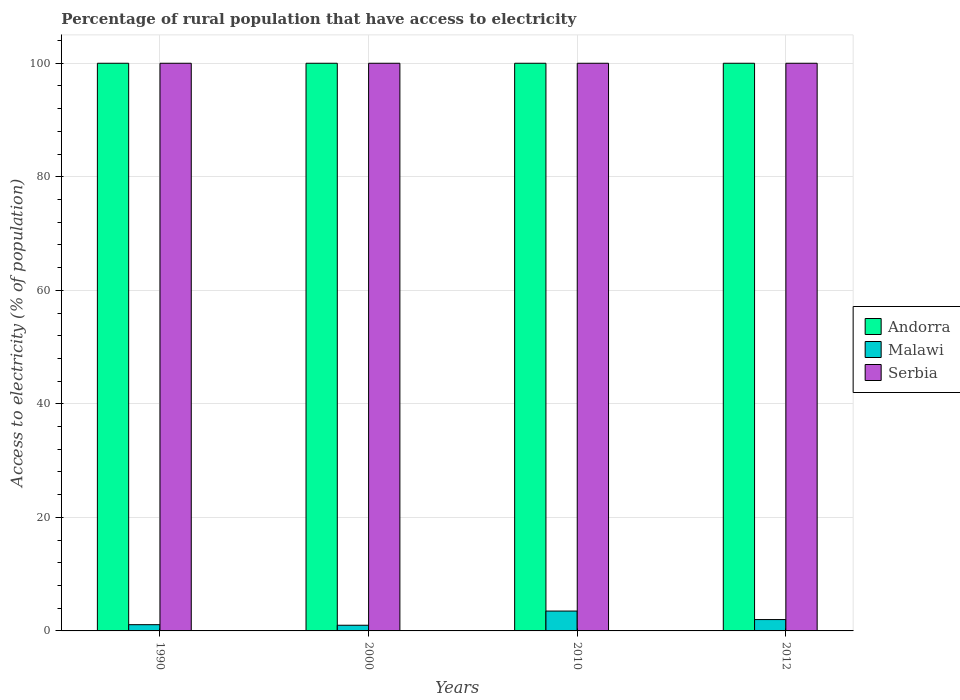How many different coloured bars are there?
Give a very brief answer. 3. How many groups of bars are there?
Give a very brief answer. 4. How many bars are there on the 2nd tick from the right?
Provide a short and direct response. 3. What is the label of the 4th group of bars from the left?
Make the answer very short. 2012. In how many cases, is the number of bars for a given year not equal to the number of legend labels?
Keep it short and to the point. 0. What is the percentage of rural population that have access to electricity in Serbia in 1990?
Give a very brief answer. 100. Across all years, what is the maximum percentage of rural population that have access to electricity in Andorra?
Offer a very short reply. 100. Across all years, what is the minimum percentage of rural population that have access to electricity in Serbia?
Your answer should be very brief. 100. In which year was the percentage of rural population that have access to electricity in Serbia maximum?
Offer a very short reply. 1990. What is the total percentage of rural population that have access to electricity in Andorra in the graph?
Your answer should be compact. 400. What is the difference between the percentage of rural population that have access to electricity in Serbia in 2012 and the percentage of rural population that have access to electricity in Malawi in 1990?
Provide a short and direct response. 98.9. What is the average percentage of rural population that have access to electricity in Serbia per year?
Offer a very short reply. 100. What is the ratio of the percentage of rural population that have access to electricity in Andorra in 2010 to that in 2012?
Your response must be concise. 1. Is the percentage of rural population that have access to electricity in Malawi in 1990 less than that in 2000?
Ensure brevity in your answer.  No. What is the difference between the highest and the second highest percentage of rural population that have access to electricity in Serbia?
Offer a terse response. 0. What does the 3rd bar from the left in 2000 represents?
Your response must be concise. Serbia. What does the 3rd bar from the right in 1990 represents?
Offer a very short reply. Andorra. How many bars are there?
Give a very brief answer. 12. What is the difference between two consecutive major ticks on the Y-axis?
Offer a very short reply. 20. Does the graph contain grids?
Provide a short and direct response. Yes. Where does the legend appear in the graph?
Your answer should be very brief. Center right. How many legend labels are there?
Your response must be concise. 3. How are the legend labels stacked?
Offer a very short reply. Vertical. What is the title of the graph?
Provide a succinct answer. Percentage of rural population that have access to electricity. What is the label or title of the X-axis?
Make the answer very short. Years. What is the label or title of the Y-axis?
Provide a short and direct response. Access to electricity (% of population). What is the Access to electricity (% of population) of Andorra in 1990?
Ensure brevity in your answer.  100. What is the Access to electricity (% of population) in Andorra in 2010?
Provide a succinct answer. 100. What is the Access to electricity (% of population) in Malawi in 2010?
Give a very brief answer. 3.5. Across all years, what is the maximum Access to electricity (% of population) in Andorra?
Ensure brevity in your answer.  100. Across all years, what is the maximum Access to electricity (% of population) of Serbia?
Give a very brief answer. 100. Across all years, what is the minimum Access to electricity (% of population) of Malawi?
Make the answer very short. 1. Across all years, what is the minimum Access to electricity (% of population) in Serbia?
Ensure brevity in your answer.  100. What is the total Access to electricity (% of population) of Serbia in the graph?
Offer a terse response. 400. What is the difference between the Access to electricity (% of population) of Malawi in 1990 and that in 2000?
Make the answer very short. 0.1. What is the difference between the Access to electricity (% of population) in Serbia in 1990 and that in 2000?
Your answer should be very brief. 0. What is the difference between the Access to electricity (% of population) in Andorra in 1990 and that in 2010?
Provide a succinct answer. 0. What is the difference between the Access to electricity (% of population) in Serbia in 1990 and that in 2010?
Your response must be concise. 0. What is the difference between the Access to electricity (% of population) in Malawi in 1990 and that in 2012?
Your answer should be very brief. -0.9. What is the difference between the Access to electricity (% of population) of Serbia in 1990 and that in 2012?
Your answer should be very brief. 0. What is the difference between the Access to electricity (% of population) in Andorra in 2000 and that in 2010?
Your answer should be very brief. 0. What is the difference between the Access to electricity (% of population) in Malawi in 2000 and that in 2010?
Ensure brevity in your answer.  -2.5. What is the difference between the Access to electricity (% of population) of Andorra in 2000 and that in 2012?
Offer a very short reply. 0. What is the difference between the Access to electricity (% of population) of Serbia in 2000 and that in 2012?
Offer a terse response. 0. What is the difference between the Access to electricity (% of population) in Andorra in 2010 and that in 2012?
Keep it short and to the point. 0. What is the difference between the Access to electricity (% of population) in Malawi in 2010 and that in 2012?
Your response must be concise. 1.5. What is the difference between the Access to electricity (% of population) of Serbia in 2010 and that in 2012?
Your answer should be compact. 0. What is the difference between the Access to electricity (% of population) in Malawi in 1990 and the Access to electricity (% of population) in Serbia in 2000?
Your answer should be compact. -98.9. What is the difference between the Access to electricity (% of population) in Andorra in 1990 and the Access to electricity (% of population) in Malawi in 2010?
Keep it short and to the point. 96.5. What is the difference between the Access to electricity (% of population) of Malawi in 1990 and the Access to electricity (% of population) of Serbia in 2010?
Your answer should be very brief. -98.9. What is the difference between the Access to electricity (% of population) in Andorra in 1990 and the Access to electricity (% of population) in Malawi in 2012?
Make the answer very short. 98. What is the difference between the Access to electricity (% of population) of Malawi in 1990 and the Access to electricity (% of population) of Serbia in 2012?
Provide a succinct answer. -98.9. What is the difference between the Access to electricity (% of population) of Andorra in 2000 and the Access to electricity (% of population) of Malawi in 2010?
Offer a terse response. 96.5. What is the difference between the Access to electricity (% of population) of Andorra in 2000 and the Access to electricity (% of population) of Serbia in 2010?
Offer a terse response. 0. What is the difference between the Access to electricity (% of population) of Malawi in 2000 and the Access to electricity (% of population) of Serbia in 2010?
Your answer should be very brief. -99. What is the difference between the Access to electricity (% of population) in Andorra in 2000 and the Access to electricity (% of population) in Malawi in 2012?
Provide a short and direct response. 98. What is the difference between the Access to electricity (% of population) of Andorra in 2000 and the Access to electricity (% of population) of Serbia in 2012?
Your answer should be very brief. 0. What is the difference between the Access to electricity (% of population) of Malawi in 2000 and the Access to electricity (% of population) of Serbia in 2012?
Your answer should be very brief. -99. What is the difference between the Access to electricity (% of population) in Andorra in 2010 and the Access to electricity (% of population) in Serbia in 2012?
Give a very brief answer. 0. What is the difference between the Access to electricity (% of population) in Malawi in 2010 and the Access to electricity (% of population) in Serbia in 2012?
Offer a very short reply. -96.5. What is the average Access to electricity (% of population) in Serbia per year?
Your answer should be very brief. 100. In the year 1990, what is the difference between the Access to electricity (% of population) in Andorra and Access to electricity (% of population) in Malawi?
Your response must be concise. 98.9. In the year 1990, what is the difference between the Access to electricity (% of population) of Malawi and Access to electricity (% of population) of Serbia?
Your answer should be very brief. -98.9. In the year 2000, what is the difference between the Access to electricity (% of population) of Malawi and Access to electricity (% of population) of Serbia?
Make the answer very short. -99. In the year 2010, what is the difference between the Access to electricity (% of population) in Andorra and Access to electricity (% of population) in Malawi?
Keep it short and to the point. 96.5. In the year 2010, what is the difference between the Access to electricity (% of population) in Andorra and Access to electricity (% of population) in Serbia?
Provide a short and direct response. 0. In the year 2010, what is the difference between the Access to electricity (% of population) in Malawi and Access to electricity (% of population) in Serbia?
Ensure brevity in your answer.  -96.5. In the year 2012, what is the difference between the Access to electricity (% of population) of Andorra and Access to electricity (% of population) of Serbia?
Make the answer very short. 0. In the year 2012, what is the difference between the Access to electricity (% of population) in Malawi and Access to electricity (% of population) in Serbia?
Your answer should be compact. -98. What is the ratio of the Access to electricity (% of population) in Andorra in 1990 to that in 2000?
Your response must be concise. 1. What is the ratio of the Access to electricity (% of population) of Malawi in 1990 to that in 2010?
Ensure brevity in your answer.  0.31. What is the ratio of the Access to electricity (% of population) of Serbia in 1990 to that in 2010?
Offer a very short reply. 1. What is the ratio of the Access to electricity (% of population) in Malawi in 1990 to that in 2012?
Your answer should be compact. 0.55. What is the ratio of the Access to electricity (% of population) in Serbia in 1990 to that in 2012?
Make the answer very short. 1. What is the ratio of the Access to electricity (% of population) of Andorra in 2000 to that in 2010?
Make the answer very short. 1. What is the ratio of the Access to electricity (% of population) in Malawi in 2000 to that in 2010?
Make the answer very short. 0.29. What is the ratio of the Access to electricity (% of population) of Serbia in 2000 to that in 2010?
Offer a terse response. 1. What is the ratio of the Access to electricity (% of population) of Malawi in 2000 to that in 2012?
Provide a succinct answer. 0.5. What is the ratio of the Access to electricity (% of population) of Serbia in 2000 to that in 2012?
Provide a short and direct response. 1. What is the ratio of the Access to electricity (% of population) in Andorra in 2010 to that in 2012?
Provide a succinct answer. 1. What is the ratio of the Access to electricity (% of population) in Malawi in 2010 to that in 2012?
Offer a terse response. 1.75. What is the difference between the highest and the second highest Access to electricity (% of population) of Malawi?
Provide a succinct answer. 1.5. What is the difference between the highest and the second highest Access to electricity (% of population) of Serbia?
Ensure brevity in your answer.  0. What is the difference between the highest and the lowest Access to electricity (% of population) in Andorra?
Provide a succinct answer. 0. 